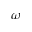Convert formula to latex. <formula><loc_0><loc_0><loc_500><loc_500>\omega</formula> 